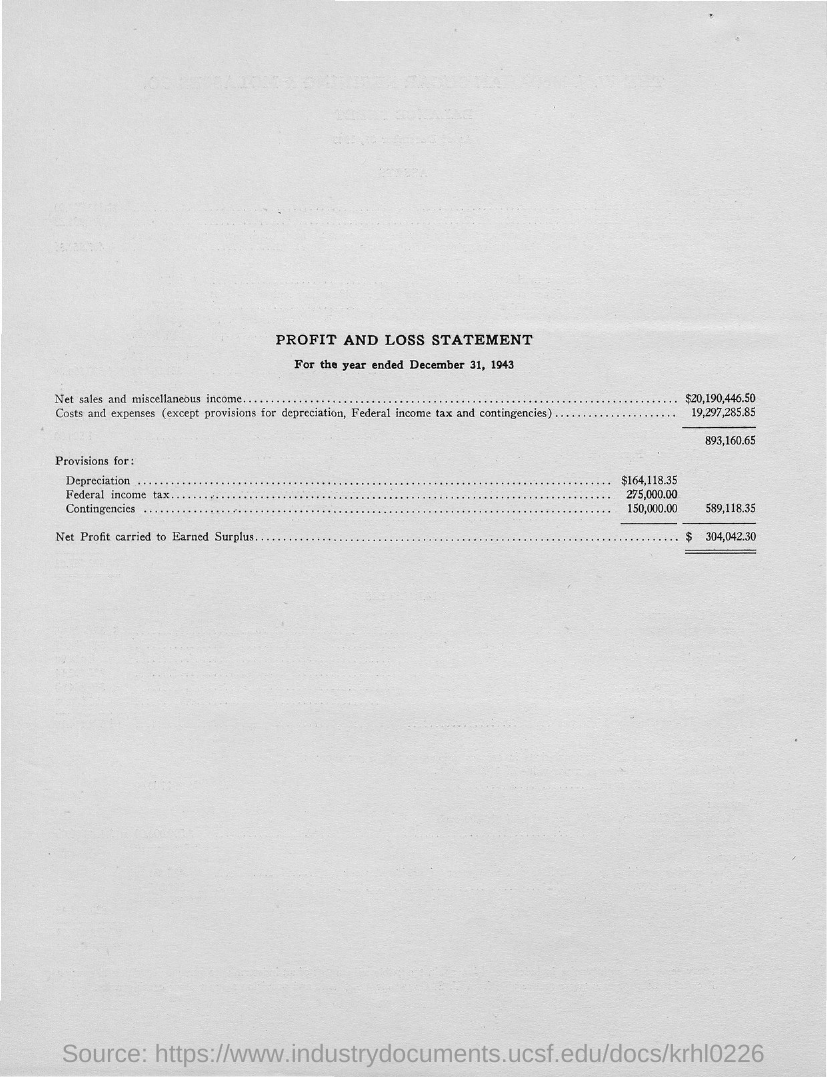Outline some significant characteristics in this image. The net sales and miscellaneous income for the given amount is 20,190,446.50. The provisions for contingencies are currently set at $150,000.00. The provisions for federal income tax are 275,000. The title of the document is a Profit and Loss Statement. The provisions for depreciation amount to $164,118.35. 